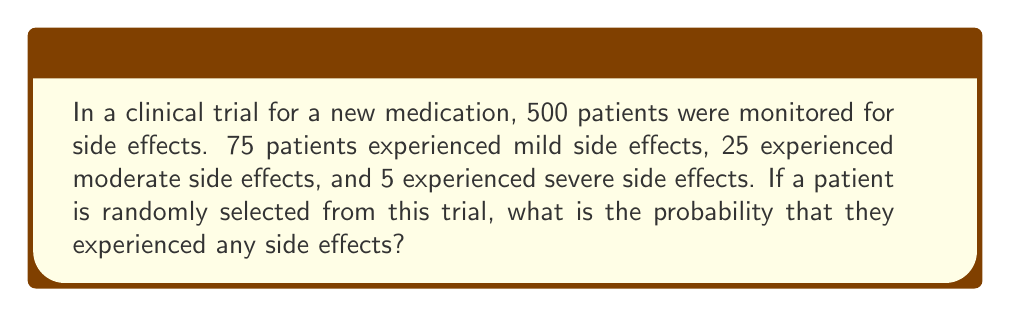Can you answer this question? Let's approach this step-by-step:

1) First, we need to calculate the total number of patients who experienced side effects:
   Mild: 75
   Moderate: 25
   Severe: 5
   Total with side effects: $75 + 25 + 5 = 105$

2) Now, we know:
   - Total number of patients in the trial: 500
   - Number of patients who experienced side effects: 105

3) The probability of an event is calculated by:

   $$P(\text{event}) = \frac{\text{number of favorable outcomes}}{\text{total number of possible outcomes}}$$

4) In this case:
   - Favorable outcomes: patients who experienced side effects (105)
   - Total possible outcomes: all patients in the trial (500)

5) Therefore, the probability is:

   $$P(\text{side effects}) = \frac{105}{500} = \frac{21}{100} = 0.21$$

6) We can express this as a percentage:
   $0.21 \times 100\% = 21\%$
Answer: 0.21 or 21% 